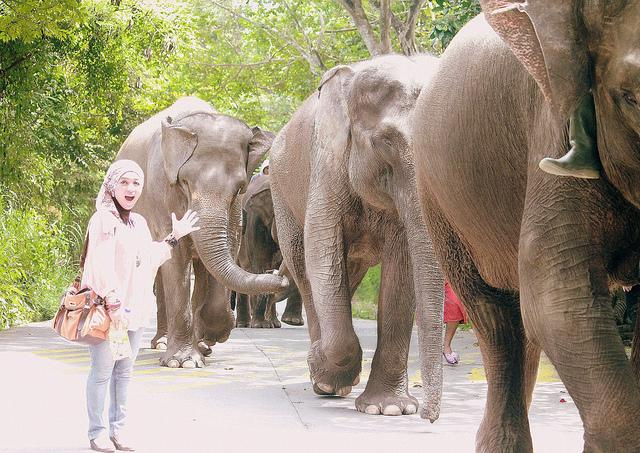What is the expression on the woman's face? surprise 